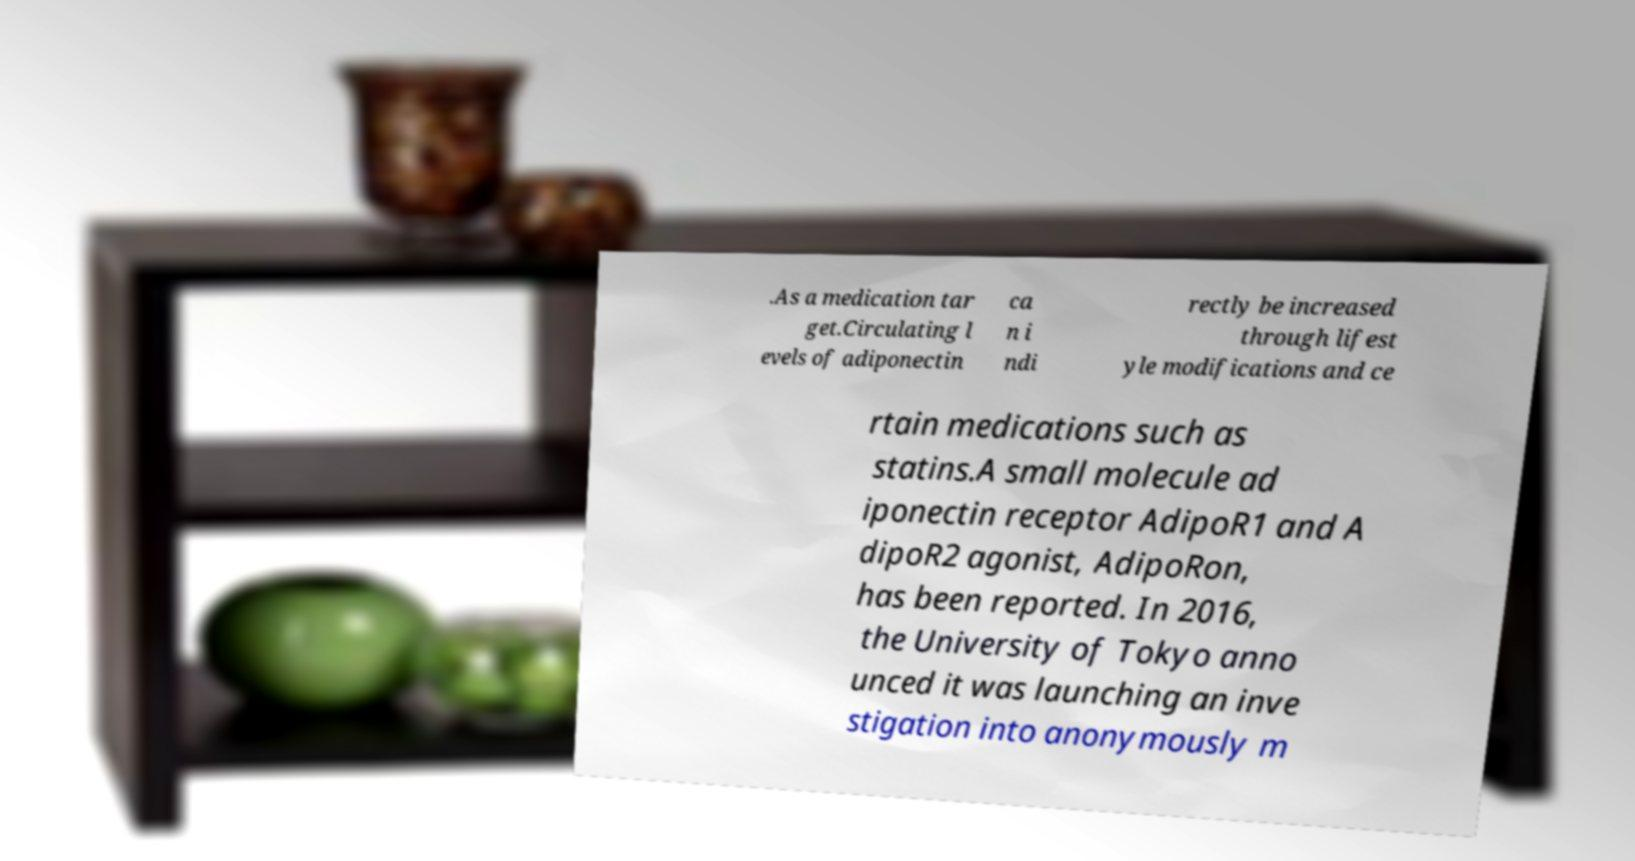Can you accurately transcribe the text from the provided image for me? .As a medication tar get.Circulating l evels of adiponectin ca n i ndi rectly be increased through lifest yle modifications and ce rtain medications such as statins.A small molecule ad iponectin receptor AdipoR1 and A dipoR2 agonist, AdipoRon, has been reported. In 2016, the University of Tokyo anno unced it was launching an inve stigation into anonymously m 